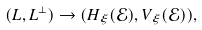Convert formula to latex. <formula><loc_0><loc_0><loc_500><loc_500>( L , L ^ { \perp } ) \rightarrow ( H _ { \xi } ( \mathcal { E } ) , V _ { \xi } ( \mathcal { E } ) ) ,</formula> 